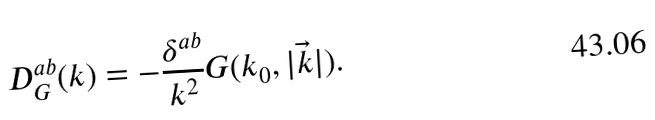<formula> <loc_0><loc_0><loc_500><loc_500>D ^ { a b } _ { G } ( k ) = - \frac { \delta ^ { a b } } { k ^ { 2 } } G ( k _ { 0 } , | \vec { k } | ) .</formula> 